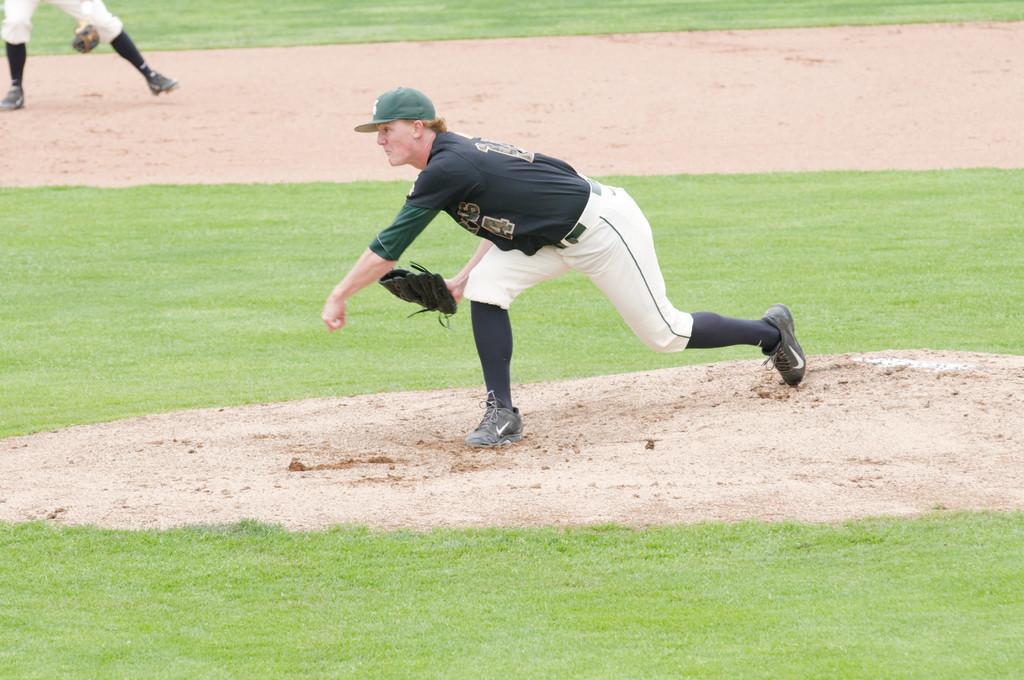Could you give a brief overview of what you see in this image? In this image I can see a person wearing a cap and bending towards the left in a stadium I can see another person in the top left corner. 